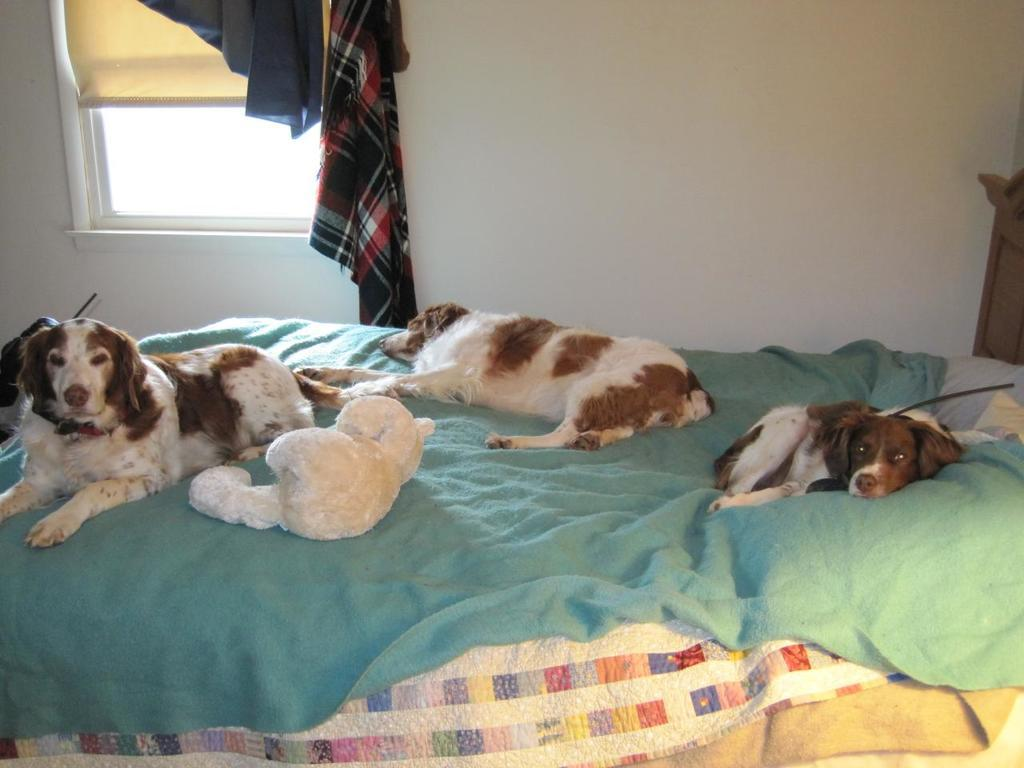How many dogs are present in the image? There are three dogs in the image. What are the dogs doing in the image? The dogs are lying on a bed. What can be seen in the background of the image? There is a wall and a window visible in the image. What type of gold jewelry can be seen on the dogs in the image? There is no gold jewelry present on the dogs in the image. What type of waves can be seen crashing against the shore in the image? There is no shore or waves present in the image; it features three dogs lying on a bed. 